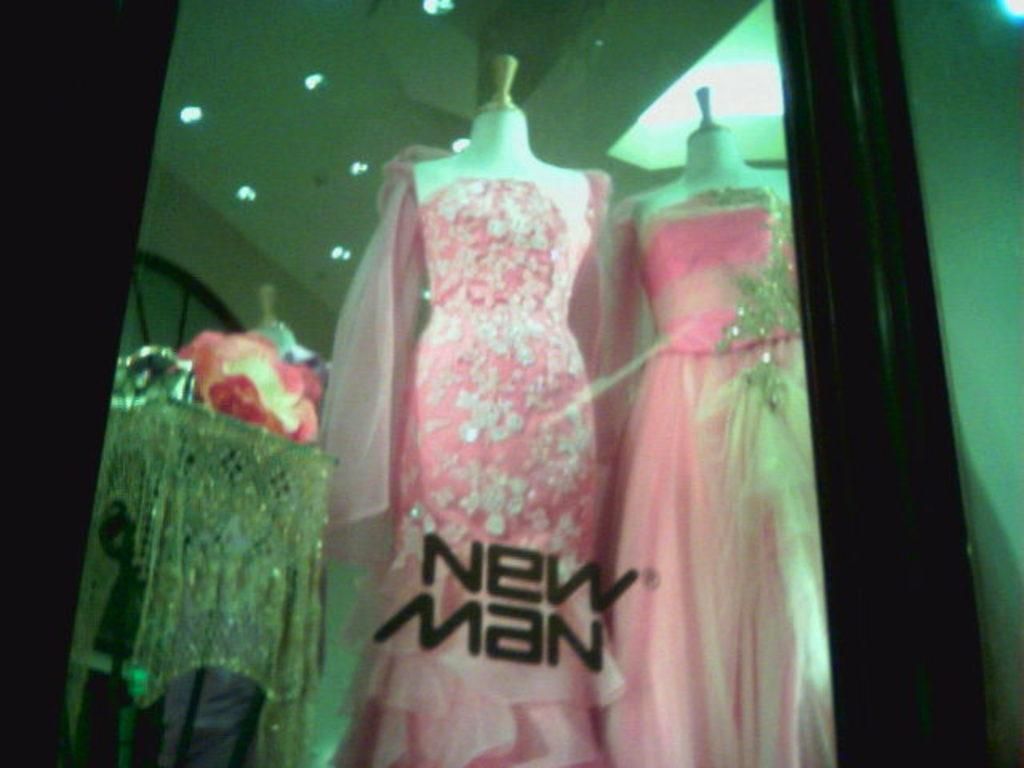What type of clothing is featured in the image? There are two pink dresses in the image. Where are the dresses placed? The dresses are on mannequins. What is the purpose of the glass structure in the image? There is a glass window in the image, which allows light to enter the space and provides a view of the outside. What type of lighting is present in the background of the image? Ceiling lights are visible in the background of the image. What type of punishment is being administered to the ink in the image? There is no ink present in the image, and therefore no punishment can be observed. What scientific experiment is being conducted in the image? There is no scientific experiment being conducted in the image; it features two pink dresses on mannequins, a glass window, and ceiling lights. 